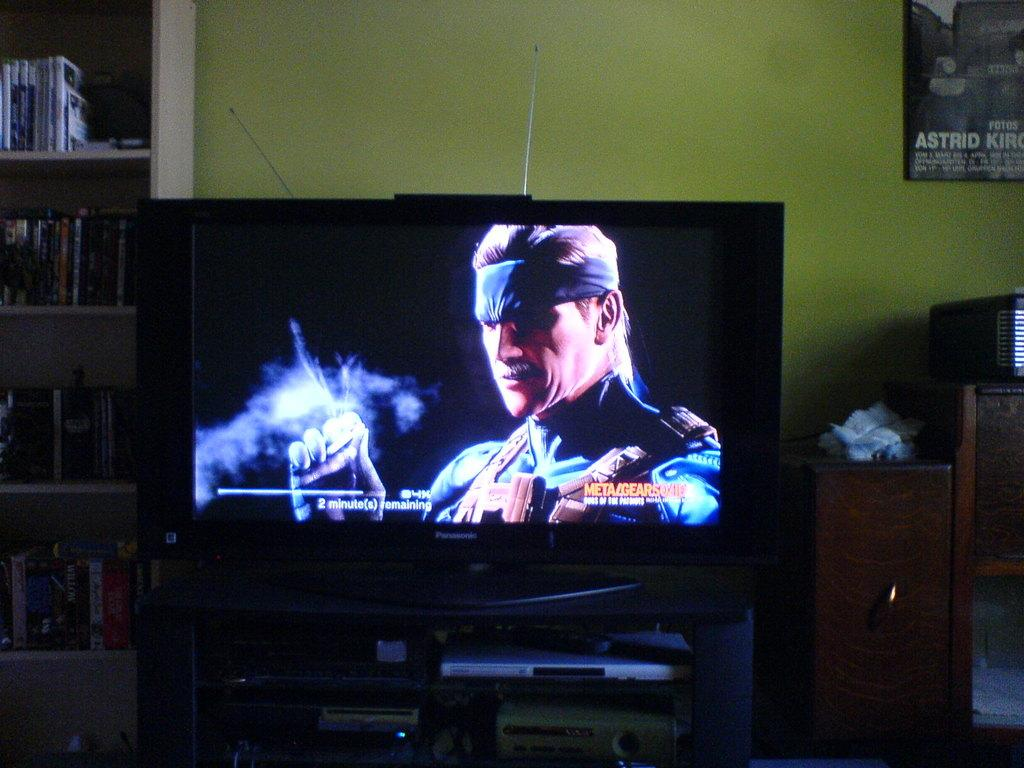<image>
Render a clear and concise summary of the photo. a television monitor paused on a video game near a poster with the word Astrid on it 